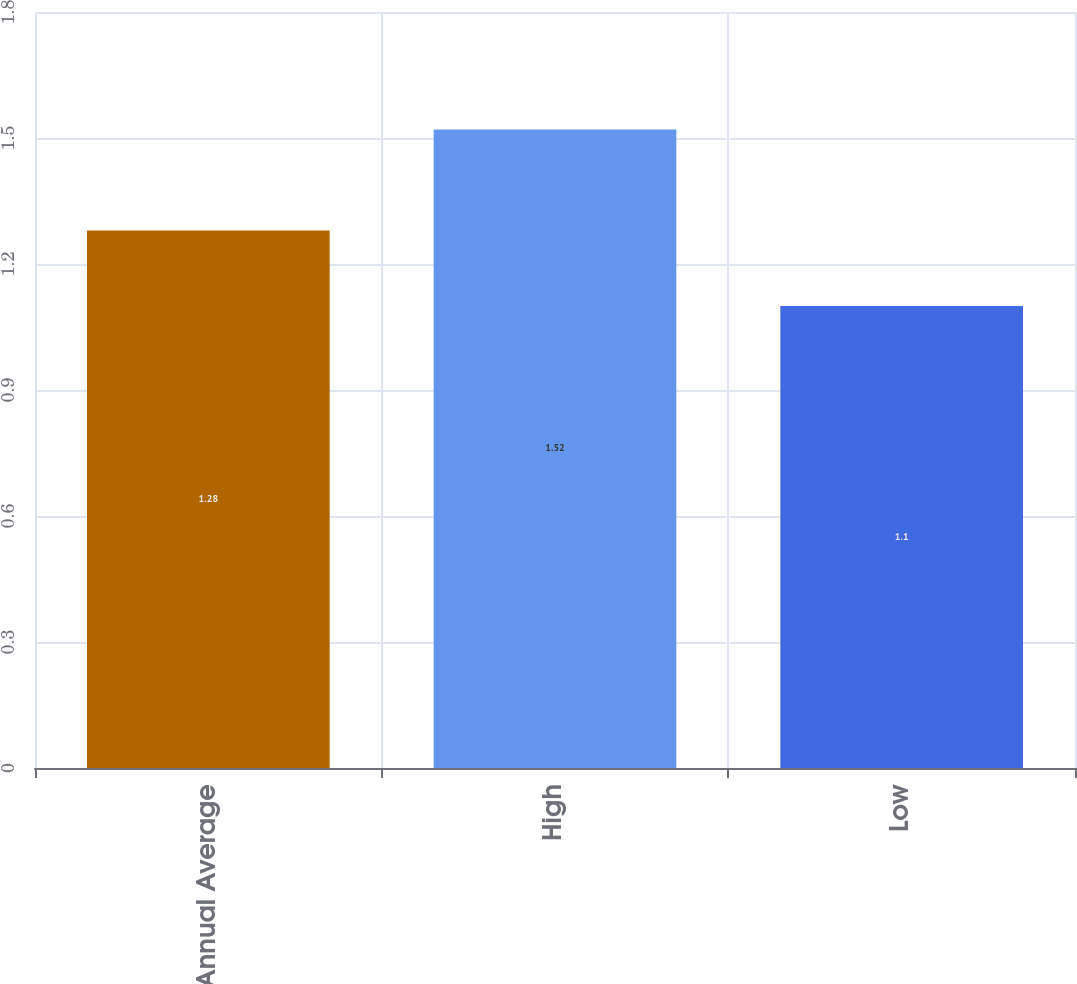<chart> <loc_0><loc_0><loc_500><loc_500><bar_chart><fcel>Annual Average<fcel>High<fcel>Low<nl><fcel>1.28<fcel>1.52<fcel>1.1<nl></chart> 